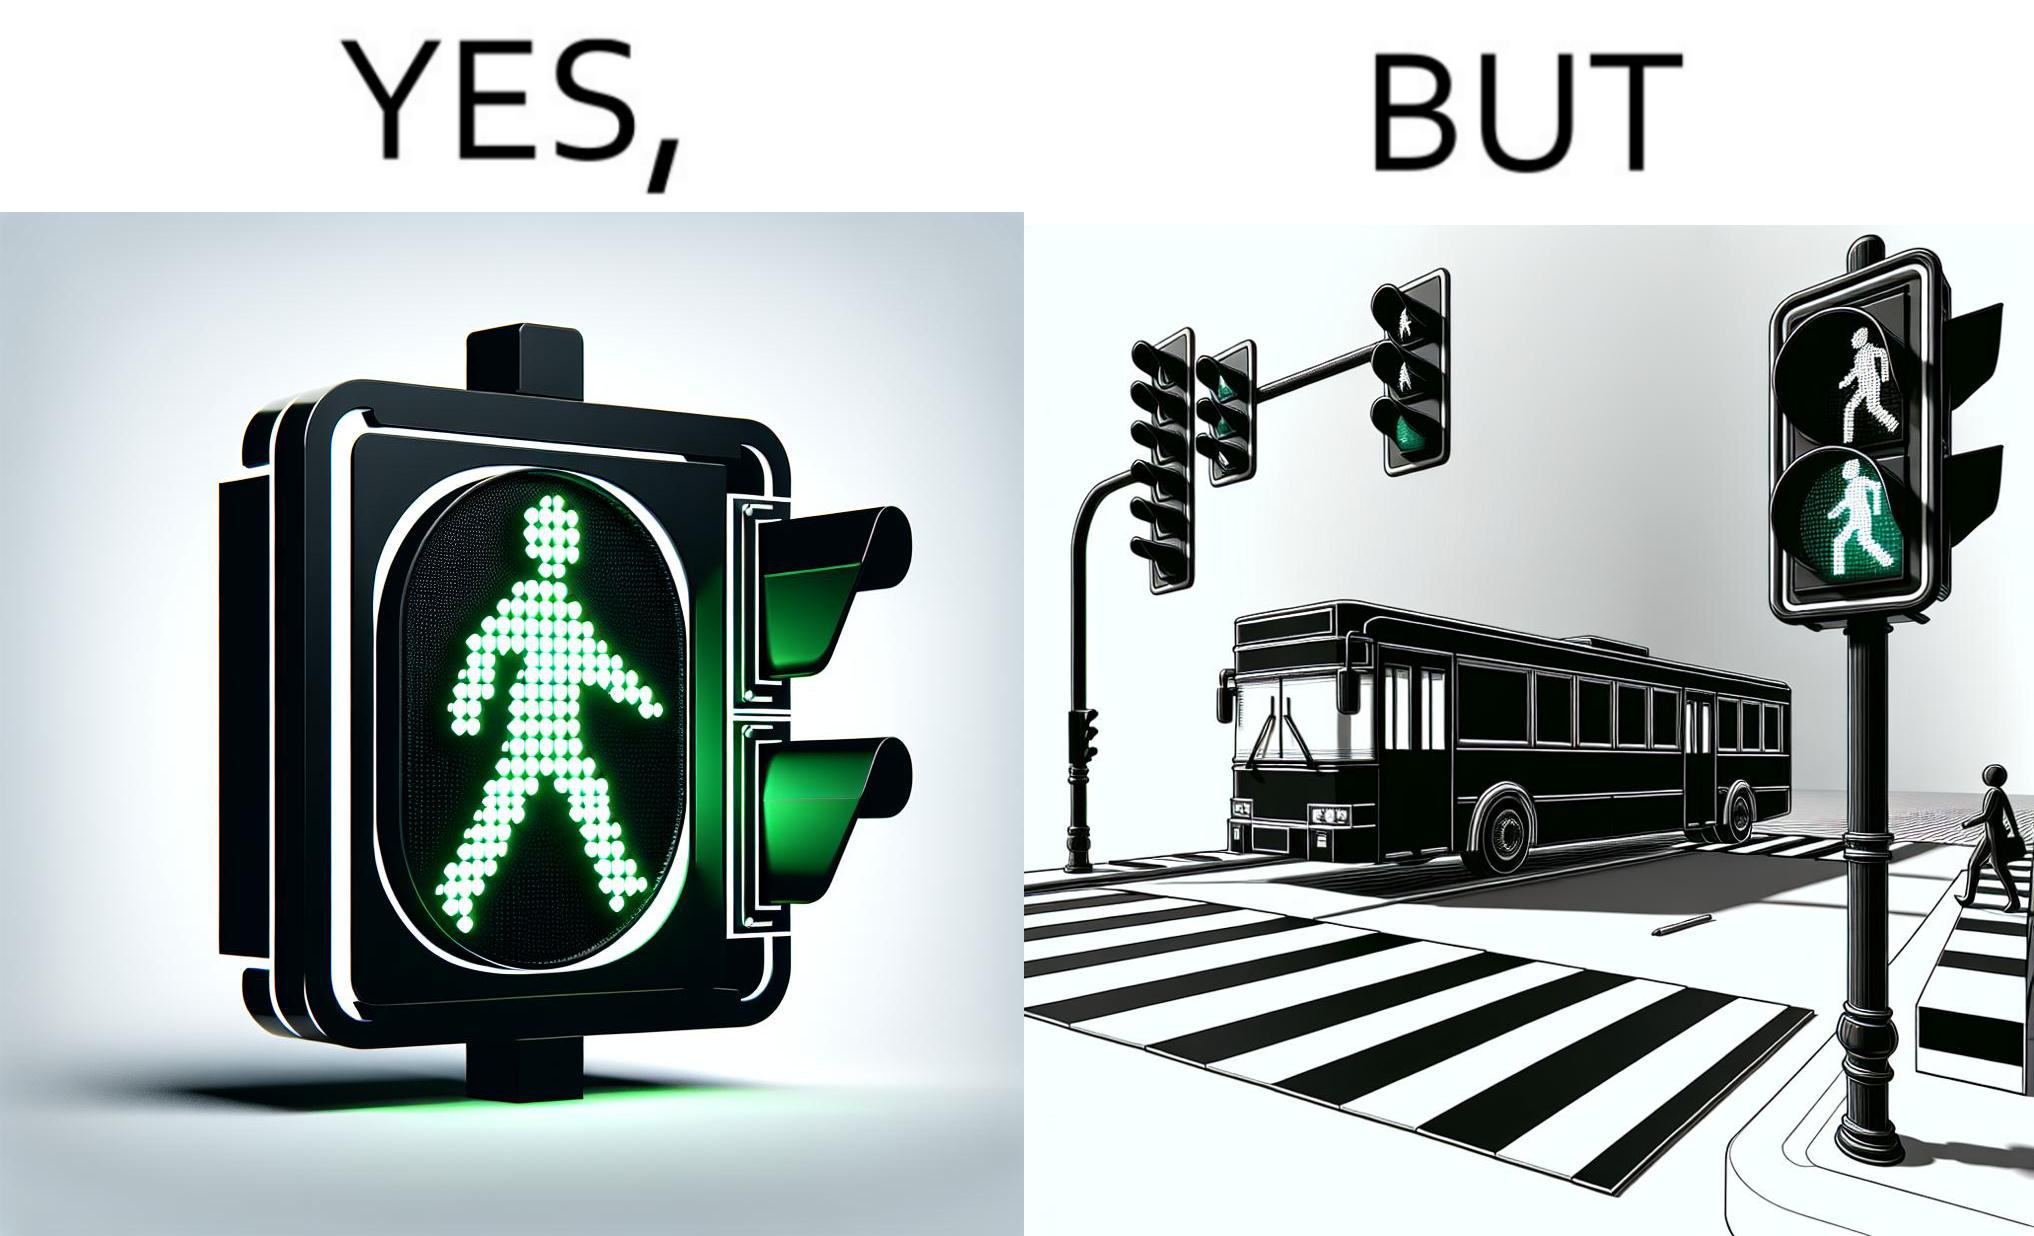Does this image contain satire or humor? Yes, this image is satirical. 